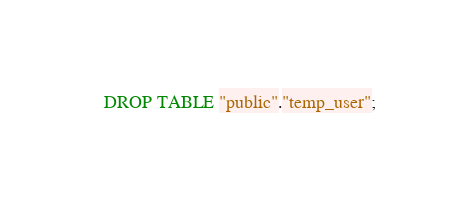Convert code to text. <code><loc_0><loc_0><loc_500><loc_500><_SQL_>DROP TABLE "public"."temp_user";
</code> 